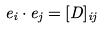Convert formula to latex. <formula><loc_0><loc_0><loc_500><loc_500>e _ { i } \cdot e _ { j } = [ D ] _ { i j }</formula> 